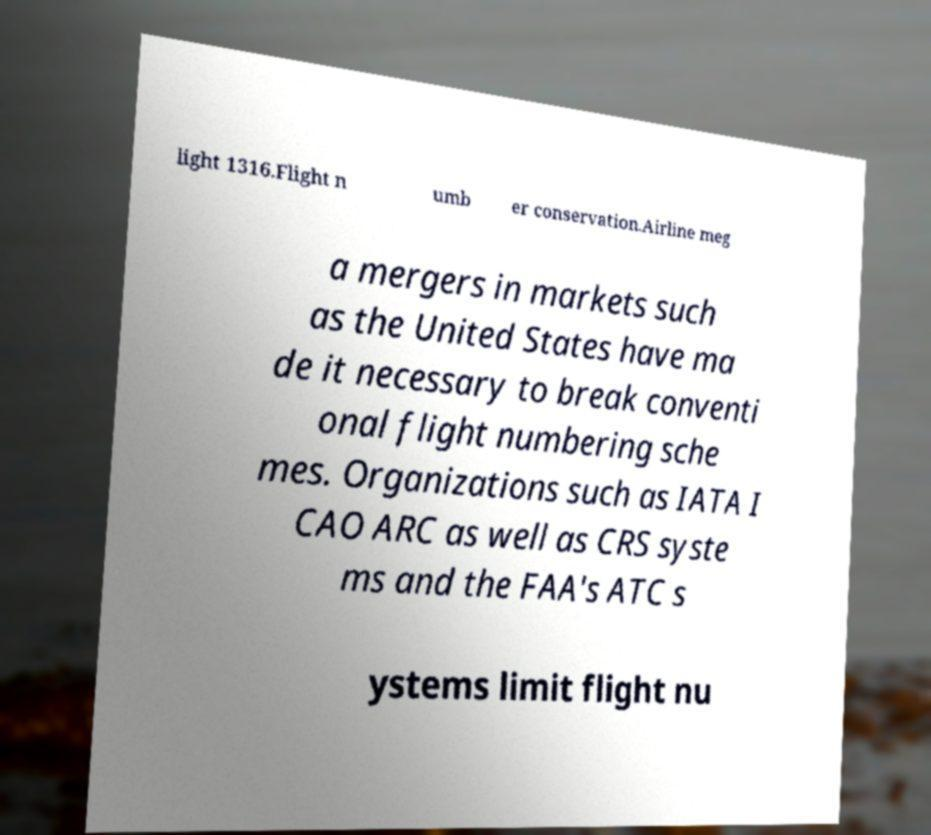Can you read and provide the text displayed in the image?This photo seems to have some interesting text. Can you extract and type it out for me? light 1316.Flight n umb er conservation.Airline meg a mergers in markets such as the United States have ma de it necessary to break conventi onal flight numbering sche mes. Organizations such as IATA I CAO ARC as well as CRS syste ms and the FAA's ATC s ystems limit flight nu 